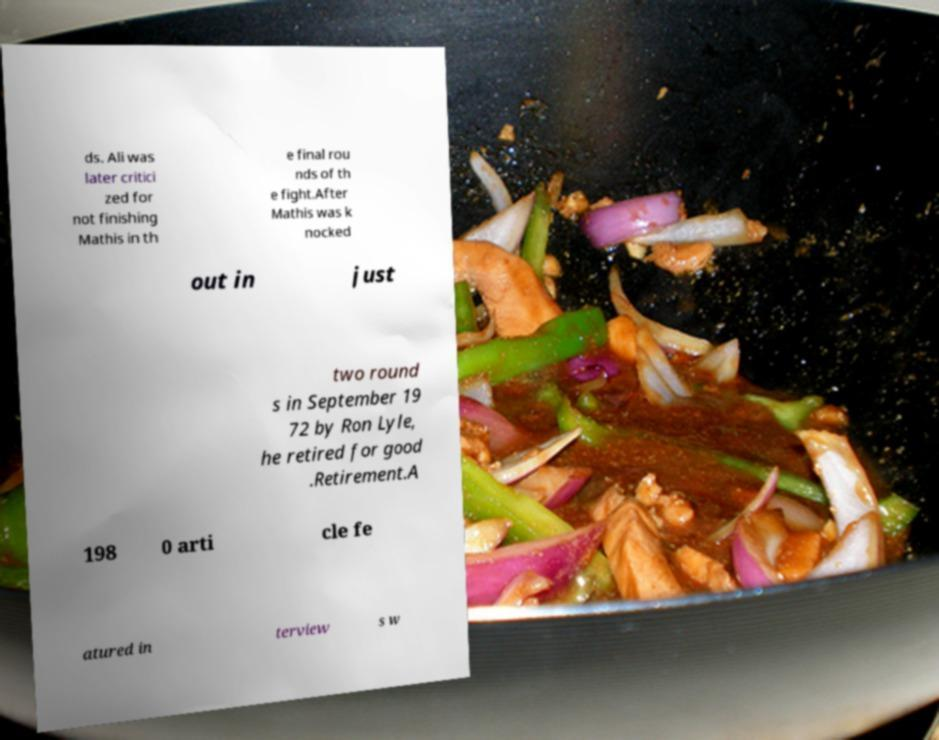Please read and relay the text visible in this image. What does it say? ds. Ali was later critici zed for not finishing Mathis in th e final rou nds of th e fight.After Mathis was k nocked out in just two round s in September 19 72 by Ron Lyle, he retired for good .Retirement.A 198 0 arti cle fe atured in terview s w 